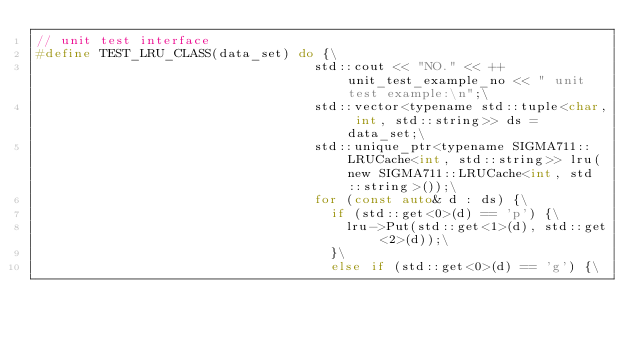<code> <loc_0><loc_0><loc_500><loc_500><_C_>// unit test interface
#define TEST_LRU_CLASS(data_set) do {\
                                   std::cout << "NO." << ++unit_test_example_no << " unit test example:\n";\
                                   std::vector<typename std::tuple<char, int, std::string>> ds = data_set;\
                                   std::unique_ptr<typename SIGMA711::LRUCache<int, std::string>> lru(new SIGMA711::LRUCache<int, std::string>());\
                                   for (const auto& d : ds) {\
                                     if (std::get<0>(d) == 'p') {\
                                       lru->Put(std::get<1>(d), std::get<2>(d));\
                                     }\
                                     else if (std::get<0>(d) == 'g') {\</code> 